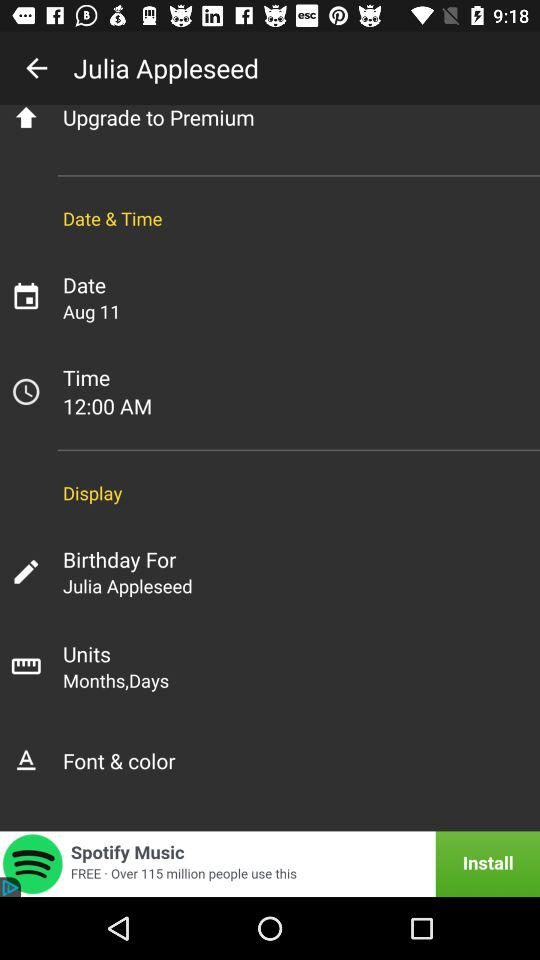Whose birthday is it for? It is for the birthday of Julia Appleseed. 